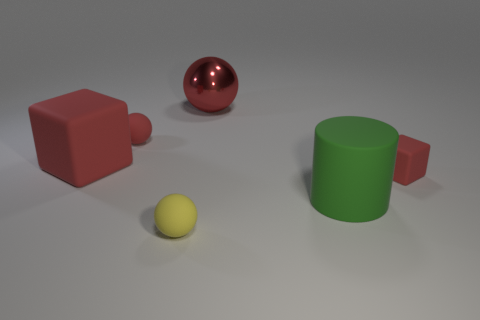Add 1 tiny cyan rubber balls. How many objects exist? 7 Subtract all blocks. How many objects are left? 4 Subtract all big matte objects. Subtract all red blocks. How many objects are left? 2 Add 5 small rubber blocks. How many small rubber blocks are left? 6 Add 2 red rubber cubes. How many red rubber cubes exist? 4 Subtract 0 gray cylinders. How many objects are left? 6 